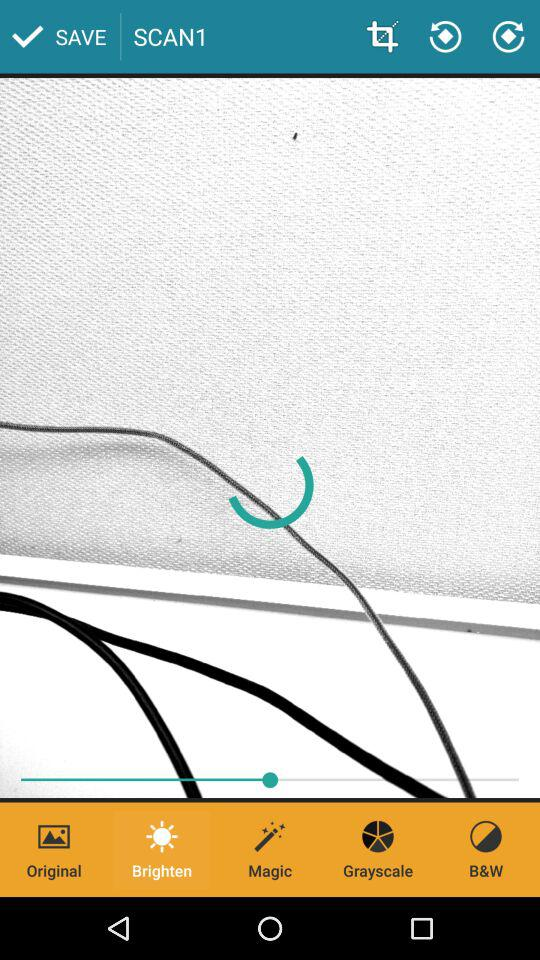Which tab is selected? The selected tab is "Brighten". 